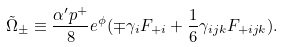<formula> <loc_0><loc_0><loc_500><loc_500>\tilde { \Omega } _ { \pm } \equiv \frac { \alpha ^ { \prime } p ^ { + } } { 8 } e ^ { \phi } ( \mp \gamma _ { i } F _ { + i } + \frac { 1 } { 6 } \gamma _ { i j k } F _ { + i j k } ) .</formula> 